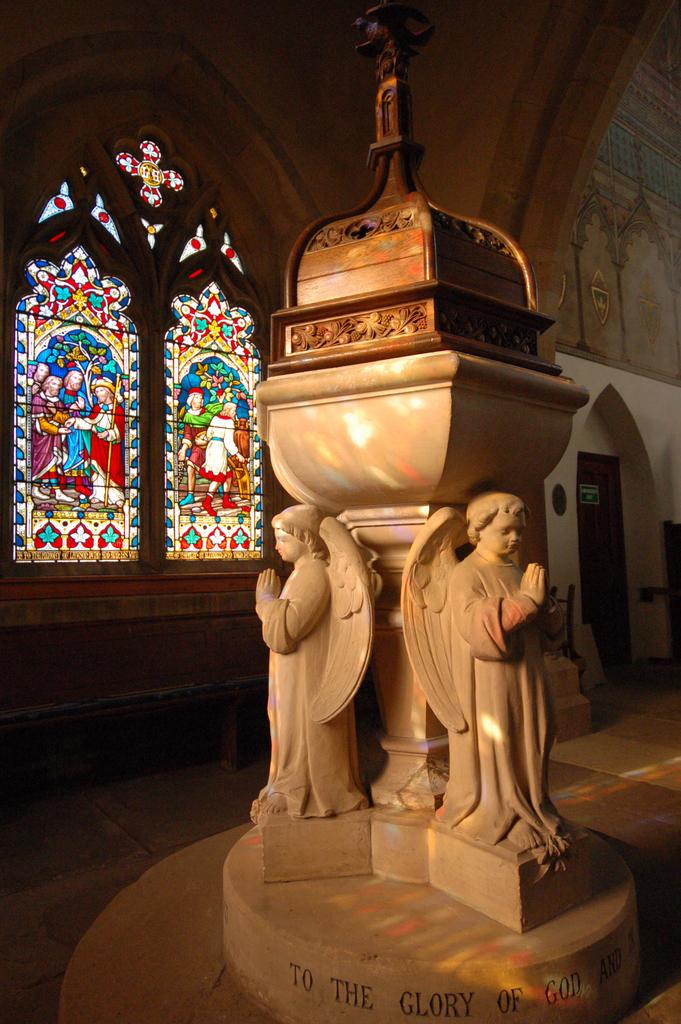What is the main subject of the image? There is a sculpture in the image. Where is the sculpture located in relation to other elements in the image? The sculpture is in front of a window. What type of bead is used to decorate the sculpture in the image? There is no bead present on the sculpture in the image. What kind of feast is being held in front of the sculpture in the image? There is no feast present in the image; it only features a sculpture in front of a window. 